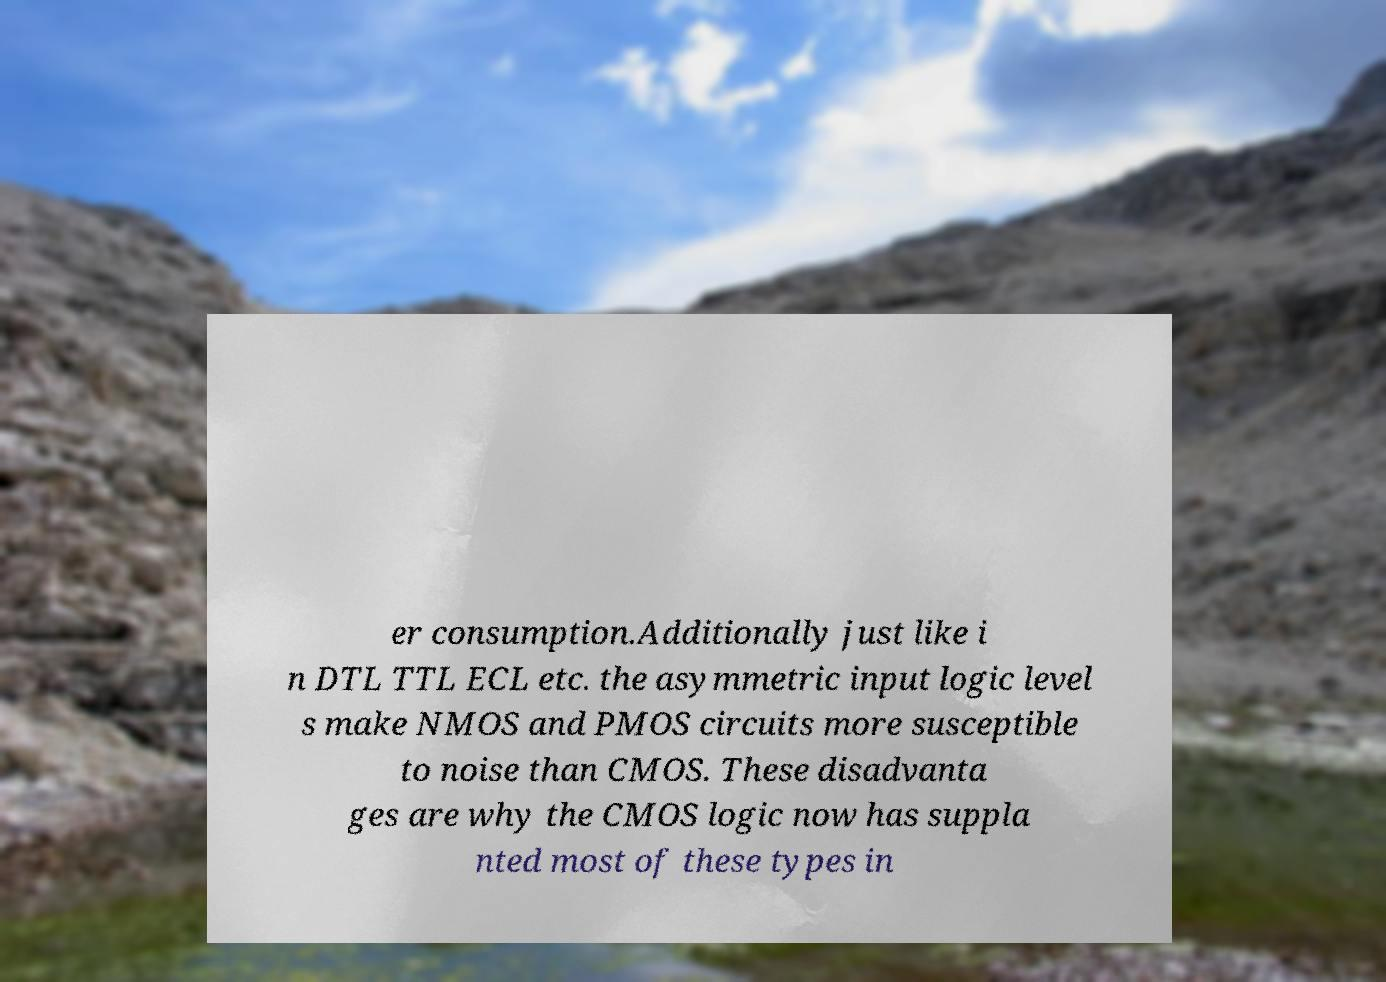Could you assist in decoding the text presented in this image and type it out clearly? er consumption.Additionally just like i n DTL TTL ECL etc. the asymmetric input logic level s make NMOS and PMOS circuits more susceptible to noise than CMOS. These disadvanta ges are why the CMOS logic now has suppla nted most of these types in 